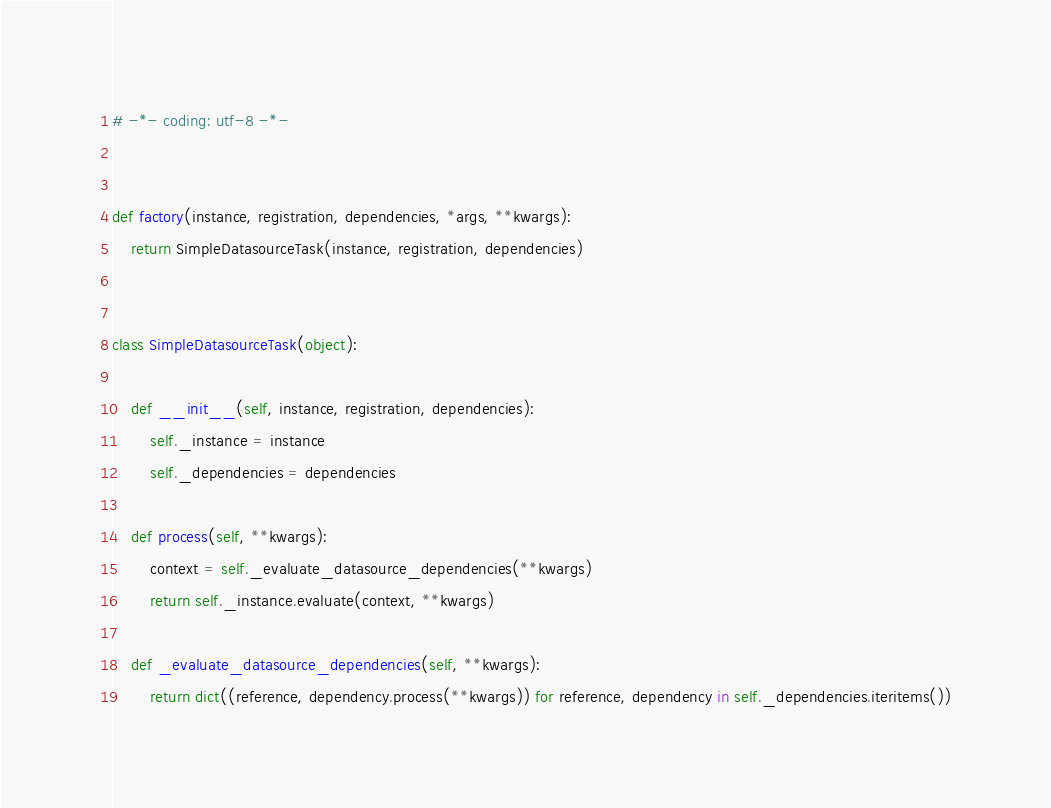<code> <loc_0><loc_0><loc_500><loc_500><_Python_># -*- coding: utf-8 -*-


def factory(instance, registration, dependencies, *args, **kwargs):
    return SimpleDatasourceTask(instance, registration, dependencies)


class SimpleDatasourceTask(object):

    def __init__(self, instance, registration, dependencies):
        self._instance = instance
        self._dependencies = dependencies

    def process(self, **kwargs):
        context = self._evaluate_datasource_dependencies(**kwargs)
        return self._instance.evaluate(context, **kwargs)

    def _evaluate_datasource_dependencies(self, **kwargs):
        return dict((reference, dependency.process(**kwargs)) for reference, dependency in self._dependencies.iteritems())
</code> 